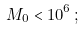Convert formula to latex. <formula><loc_0><loc_0><loc_500><loc_500>M _ { 0 } < 1 0 ^ { 6 } \, ;</formula> 